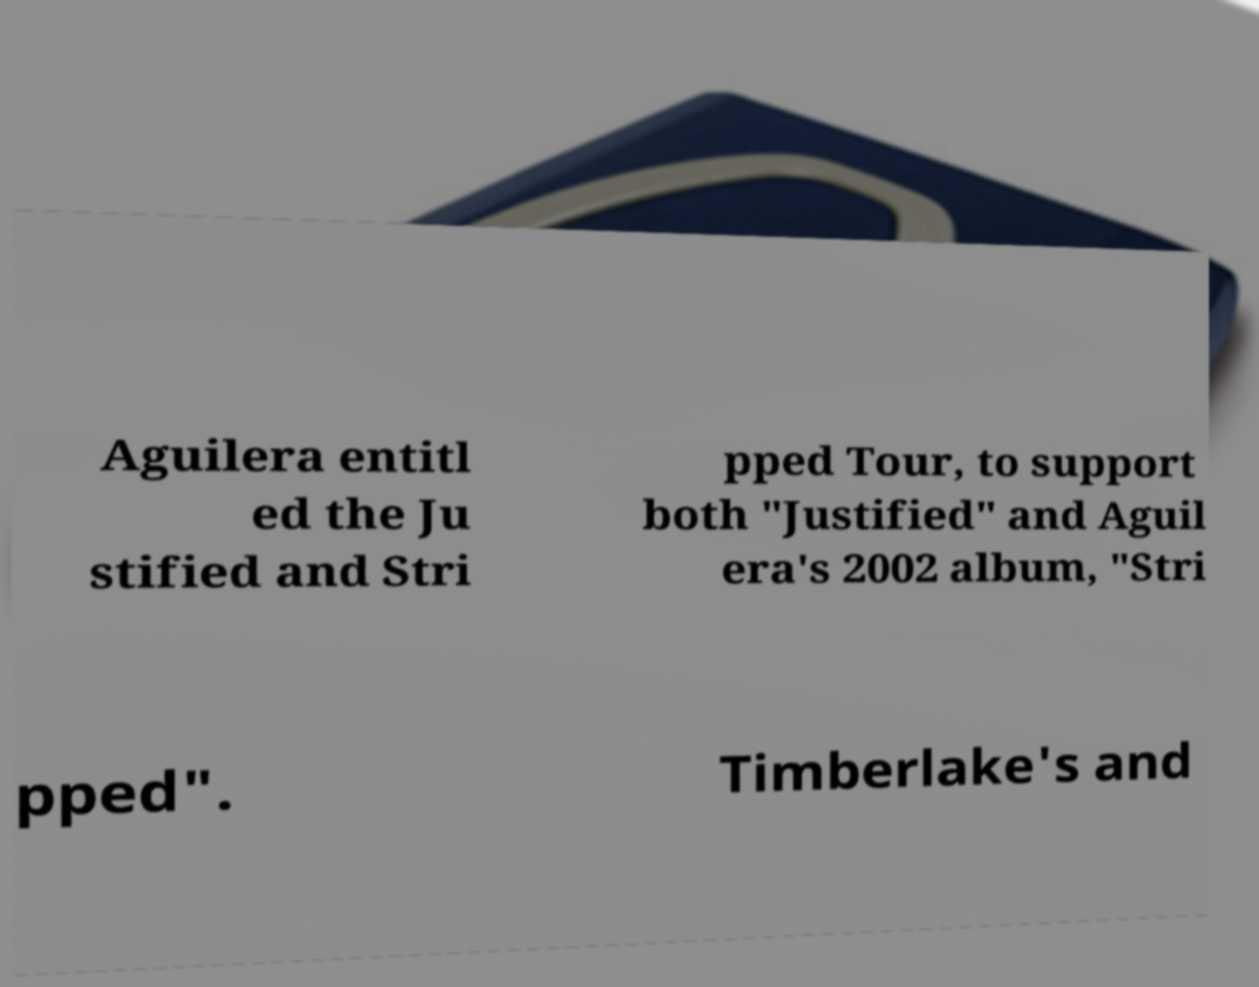I need the written content from this picture converted into text. Can you do that? Aguilera entitl ed the Ju stified and Stri pped Tour, to support both "Justified" and Aguil era's 2002 album, "Stri pped". Timberlake's and 